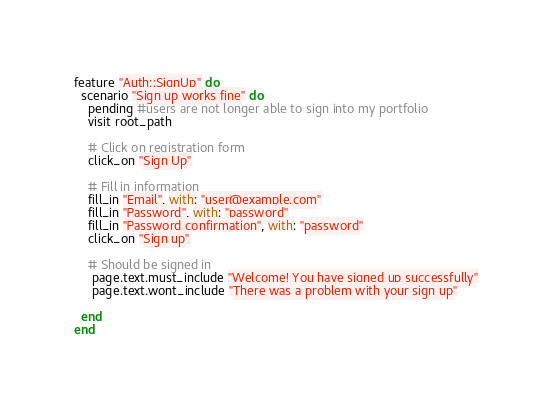Convert code to text. <code><loc_0><loc_0><loc_500><loc_500><_Ruby_>feature "Auth::SignUp" do
  scenario "Sign up works fine" do
    pending #users are not longer able to sign into my portfolio
    visit root_path

    # Click on registration form
    click_on "Sign Up"

    # Fill in information
    fill_in "Email", with: "user@example.com"
    fill_in "Password", with: "password"
    fill_in "Password confirmation", with: "password"
    click_on "Sign up"

    # Should be signed in
     page.text.must_include "Welcome! You have signed up successfully"
     page.text.wont_include "There was a problem with your sign up"

  end
end
</code> 